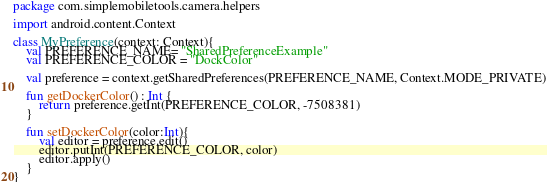<code> <loc_0><loc_0><loc_500><loc_500><_Kotlin_>package com.simplemobiletools.camera.helpers

import android.content.Context

class MyPreference(context: Context){
    val PREFERENCE_NAME= "SharedPreferenceExample"
    val PREFERENCE_COLOR = "DockColor"

    val preference = context.getSharedPreferences(PREFERENCE_NAME, Context.MODE_PRIVATE)

    fun getDockerColor() : Int {
        return preference.getInt(PREFERENCE_COLOR, -7508381)
    }

    fun setDockerColor(color:Int){
        val editor = preference.edit()
        editor.putInt(PREFERENCE_COLOR, color)
        editor.apply()
    }
}
</code> 